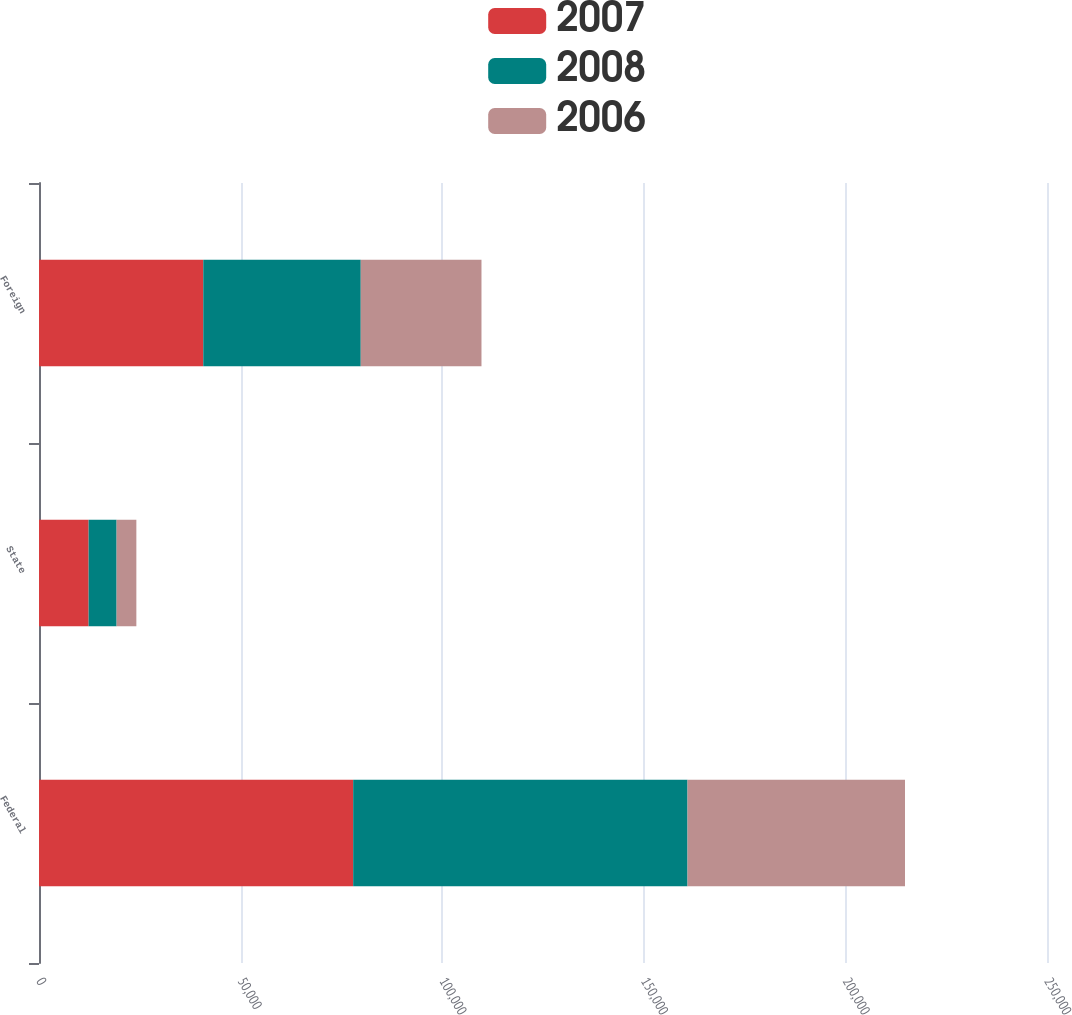Convert chart to OTSL. <chart><loc_0><loc_0><loc_500><loc_500><stacked_bar_chart><ecel><fcel>Federal<fcel>State<fcel>Foreign<nl><fcel>2007<fcel>77920<fcel>12309<fcel>40739<nl><fcel>2008<fcel>82923<fcel>6940<fcel>39062<nl><fcel>2006<fcel>53937<fcel>4896<fcel>29942<nl></chart> 